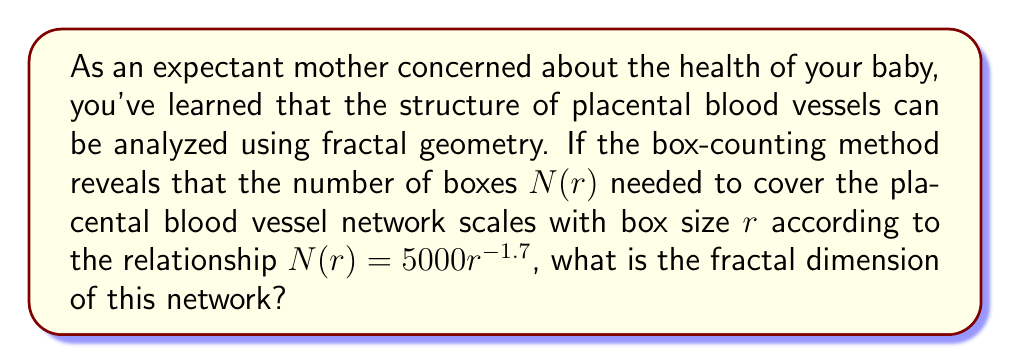Give your solution to this math problem. Let's approach this step-by-step:

1) The fractal dimension $D$ is defined by the box-counting method as:

   $$D = -\lim_{r \to 0} \frac{\log N(r)}{\log r}$$

2) In this case, we're given the relationship:

   $$N(r) = 5000r^{-1.7}$$

3) Taking the logarithm of both sides:

   $$\log N(r) = \log(5000) - 1.7 \log r$$

4) Now, we can calculate the limit:

   $$D = -\lim_{r \to 0} \frac{\log N(r)}{\log r} = -\lim_{r \to 0} \frac{\log(5000) - 1.7 \log r}{\log r}$$

5) As $r$ approaches 0, $\log r$ approaches negative infinity, so the $\log(5000)$ term becomes negligible:

   $$D = -\lim_{r \to 0} \frac{- 1.7 \log r}{\log r} = 1.7$$

Therefore, the fractal dimension of the placental blood vessel network is 1.7.

This value between 1 and 2 indicates that the network is more complex than a simple line (dimension 1) but doesn't quite fill a plane (dimension 2), which is typical for biological branching structures.
Answer: 1.7 